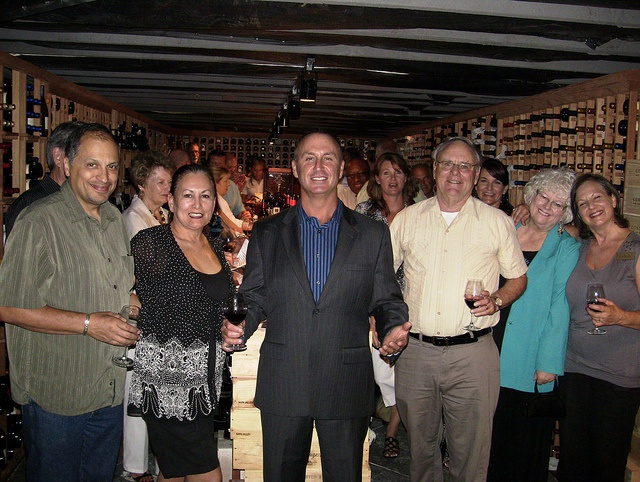Describe the objects in this image and their specific colors. I can see people in black, brown, and gray tones, people in black and gray tones, people in black, gray, tan, and beige tones, people in black, gray, and darkgray tones, and people in black, gray, brown, and maroon tones in this image. 